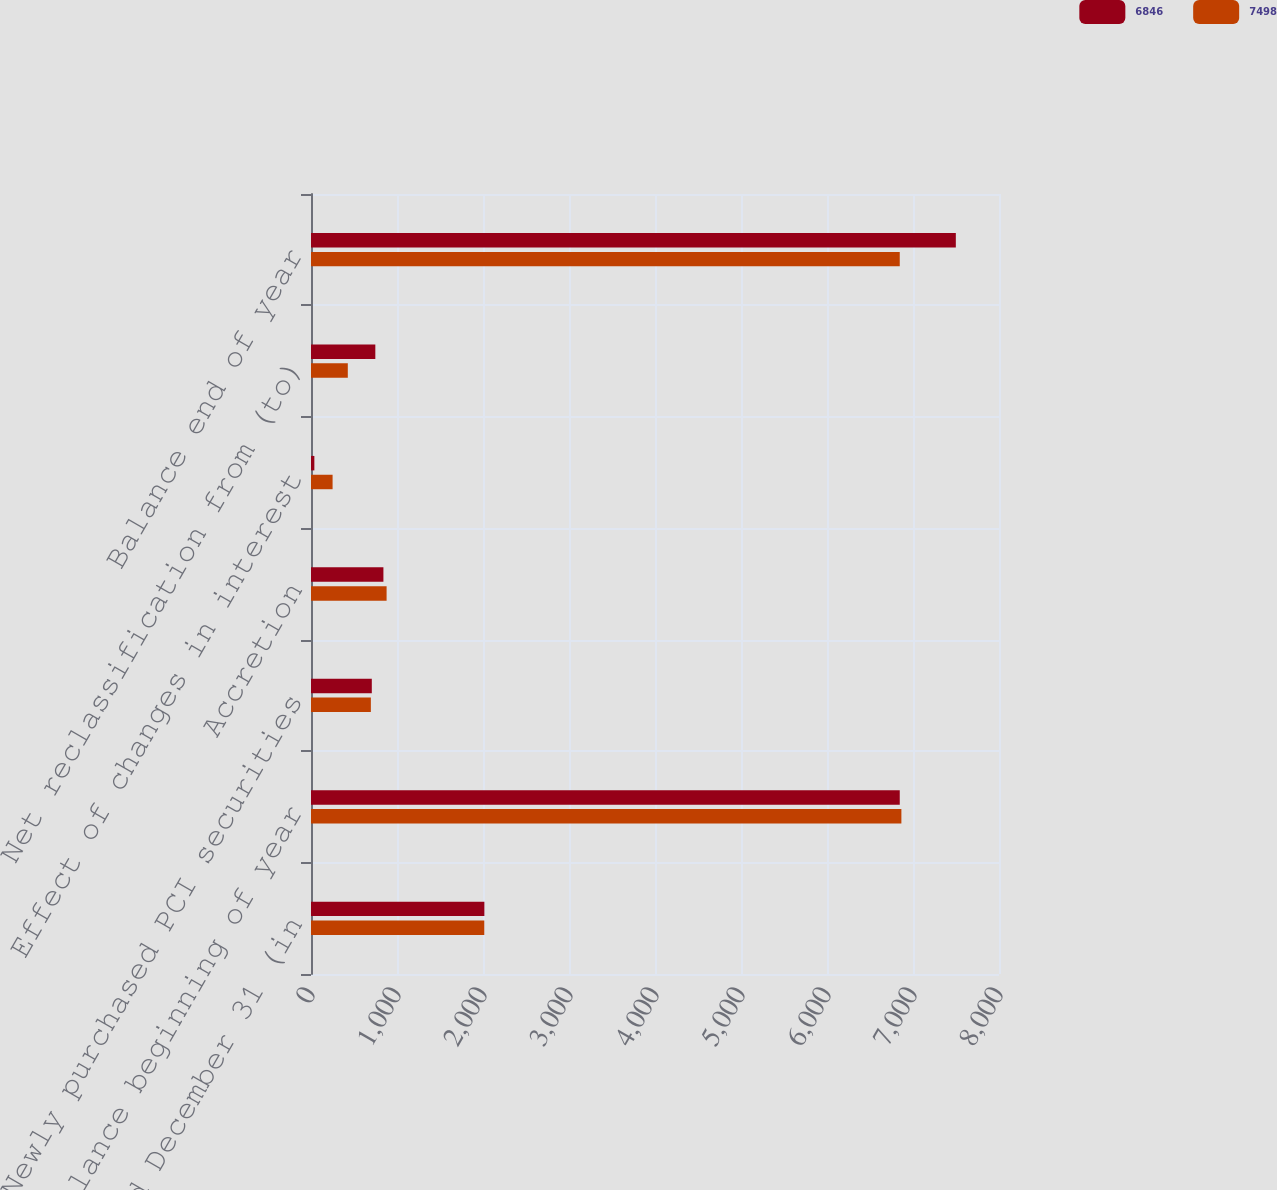<chart> <loc_0><loc_0><loc_500><loc_500><stacked_bar_chart><ecel><fcel>Years Ended December 31 (in<fcel>Balance beginning of year<fcel>Newly purchased PCI securities<fcel>Accretion<fcel>Effect of changes in interest<fcel>Net reclassification from (to)<fcel>Balance end of year<nl><fcel>6846<fcel>2016<fcel>6846<fcel>707<fcel>842<fcel>39<fcel>748<fcel>7498<nl><fcel>7498<fcel>2015<fcel>6865<fcel>696<fcel>879<fcel>251<fcel>428<fcel>6846<nl></chart> 